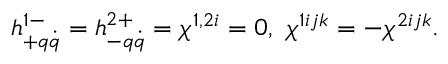Convert formula to latex. <formula><loc_0><loc_0><loc_500><loc_500>h _ { + q \dot { q } } ^ { 1 - } = h _ { - q \dot { q } } ^ { 2 + } = \chi ^ { 1 , 2 i } = 0 , \ \chi ^ { 1 i j k } = - \chi ^ { 2 i j k } .</formula> 